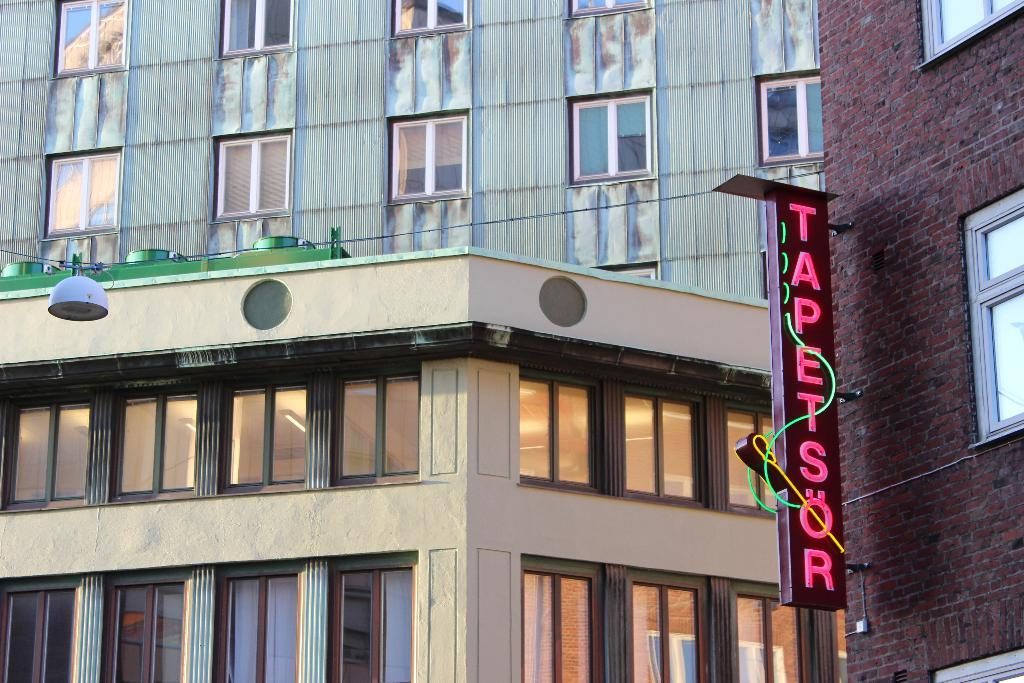What type of structures can be seen in the image? There are buildings in the image. What feature is common among the buildings? There are windows in the image. What else can be seen in the image besides the buildings? There is a wire and an object on the left side of the image, as well as a board on the right side of the image. What is written on the board? There is text on the board. What type of spoon is being used to stir the fan in the image? There is no spoon or fan present in the image. What type of voyage is depicted in the image? There is no voyage depicted in the image; it features buildings, windows, a wire, an object, a board, and text. 